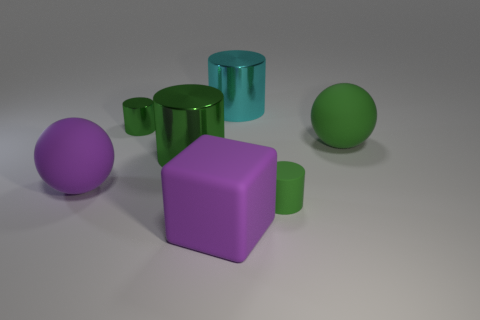Subtract all brown cubes. How many green cylinders are left? 3 Add 3 yellow rubber spheres. How many objects exist? 10 Subtract all blocks. How many objects are left? 6 Add 1 large purple matte cubes. How many large purple matte cubes exist? 2 Subtract 0 yellow spheres. How many objects are left? 7 Subtract all large spheres. Subtract all big purple cubes. How many objects are left? 4 Add 1 purple rubber objects. How many purple rubber objects are left? 3 